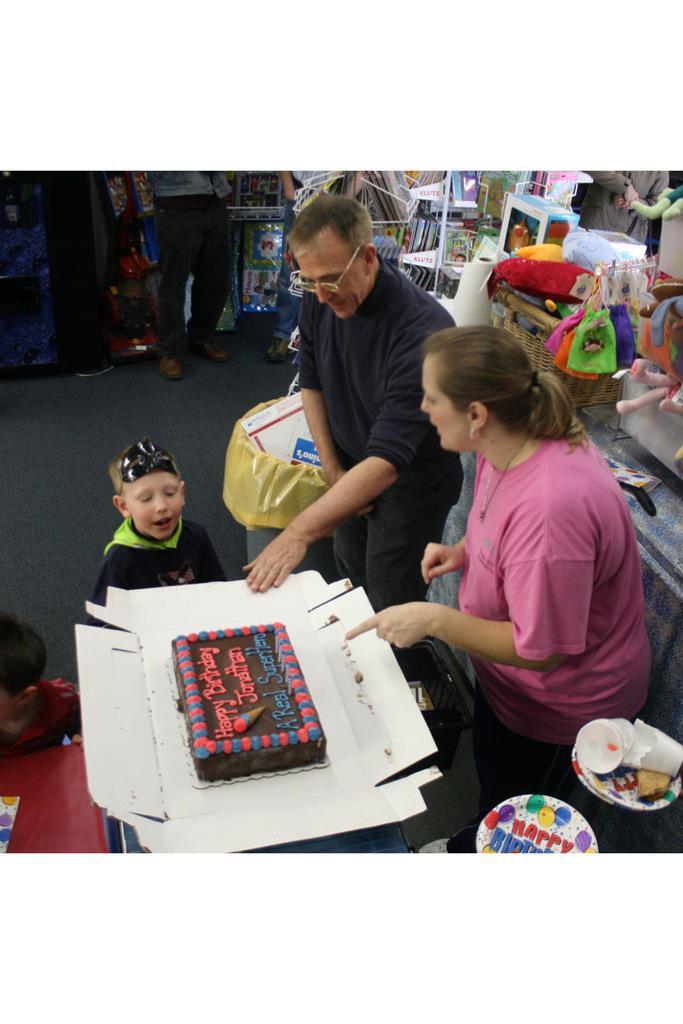Can you describe this image briefly? In this image I can see a man a woman and a boy. Here I can see a cake. In the background I can see few more people are standing. I can also see he is wearing specs. 